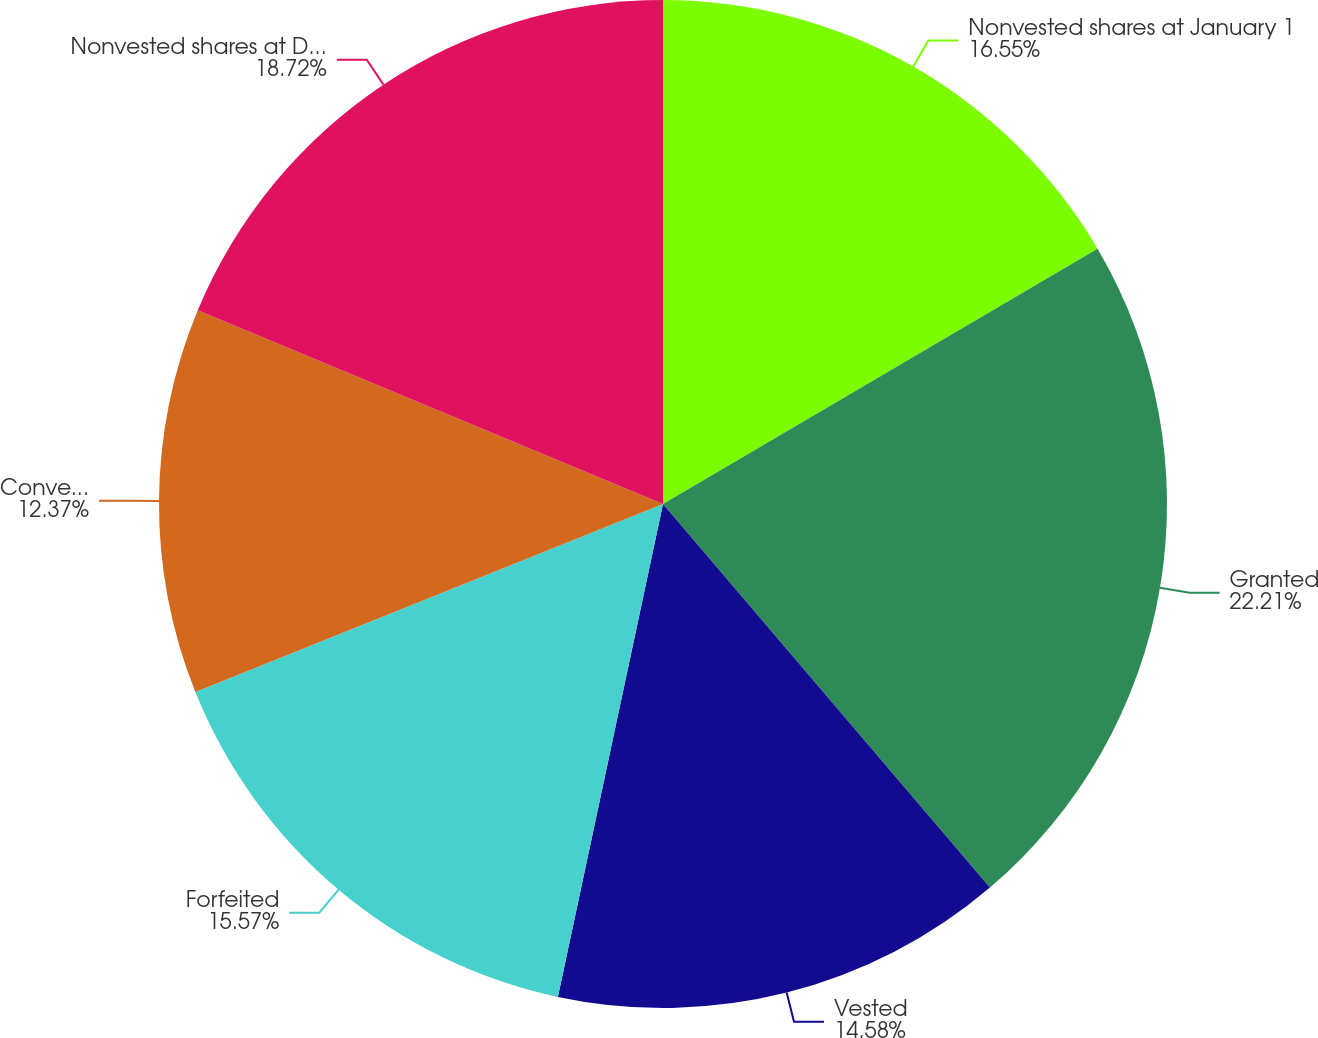Convert chart. <chart><loc_0><loc_0><loc_500><loc_500><pie_chart><fcel>Nonvested shares at January 1<fcel>Granted<fcel>Vested<fcel>Forfeited<fcel>Converted to KBR Inc<fcel>Nonvested shares at December<nl><fcel>16.55%<fcel>22.22%<fcel>14.58%<fcel>15.57%<fcel>12.37%<fcel>18.72%<nl></chart> 